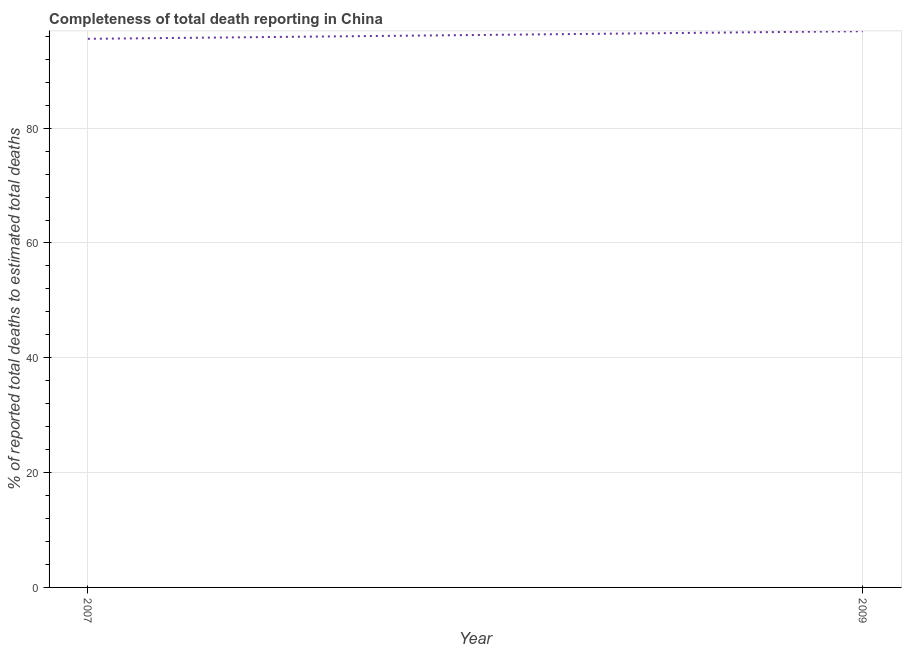What is the completeness of total death reports in 2007?
Ensure brevity in your answer.  95.56. Across all years, what is the maximum completeness of total death reports?
Offer a very short reply. 96.89. Across all years, what is the minimum completeness of total death reports?
Make the answer very short. 95.56. In which year was the completeness of total death reports maximum?
Ensure brevity in your answer.  2009. In which year was the completeness of total death reports minimum?
Your answer should be compact. 2007. What is the sum of the completeness of total death reports?
Give a very brief answer. 192.44. What is the difference between the completeness of total death reports in 2007 and 2009?
Your answer should be very brief. -1.33. What is the average completeness of total death reports per year?
Offer a terse response. 96.22. What is the median completeness of total death reports?
Give a very brief answer. 96.22. In how many years, is the completeness of total death reports greater than 12 %?
Your response must be concise. 2. What is the ratio of the completeness of total death reports in 2007 to that in 2009?
Your answer should be very brief. 0.99. Is the completeness of total death reports in 2007 less than that in 2009?
Provide a short and direct response. Yes. Does the completeness of total death reports monotonically increase over the years?
Your answer should be compact. Yes. How many years are there in the graph?
Keep it short and to the point. 2. What is the difference between two consecutive major ticks on the Y-axis?
Provide a short and direct response. 20. Are the values on the major ticks of Y-axis written in scientific E-notation?
Ensure brevity in your answer.  No. Does the graph contain any zero values?
Provide a short and direct response. No. Does the graph contain grids?
Keep it short and to the point. Yes. What is the title of the graph?
Your response must be concise. Completeness of total death reporting in China. What is the label or title of the Y-axis?
Offer a terse response. % of reported total deaths to estimated total deaths. What is the % of reported total deaths to estimated total deaths in 2007?
Your answer should be very brief. 95.56. What is the % of reported total deaths to estimated total deaths in 2009?
Ensure brevity in your answer.  96.89. What is the difference between the % of reported total deaths to estimated total deaths in 2007 and 2009?
Offer a terse response. -1.33. 